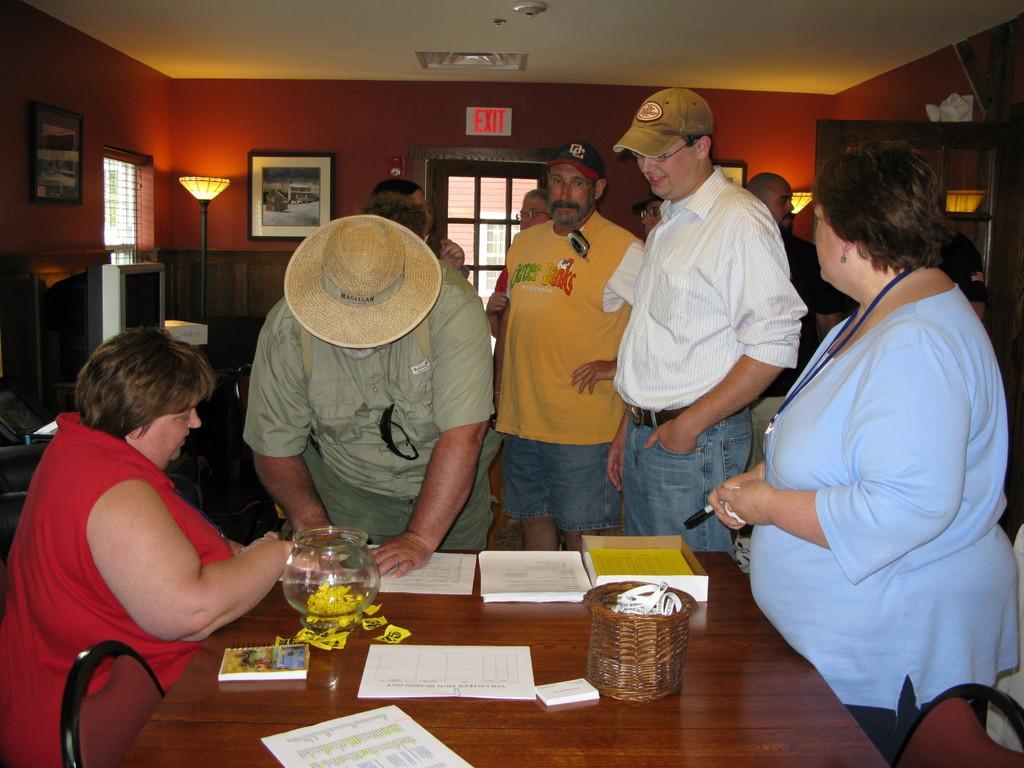In one or two sentences, can you explain what this image depicts? In this image we can see a lady wearing red dress is sitting on the chair near the table. There are glass jar, book, papers and basket on the table. These people are standing near the table. In the background of the image we can see a television, photo frames, lamp, exit board and windows. 